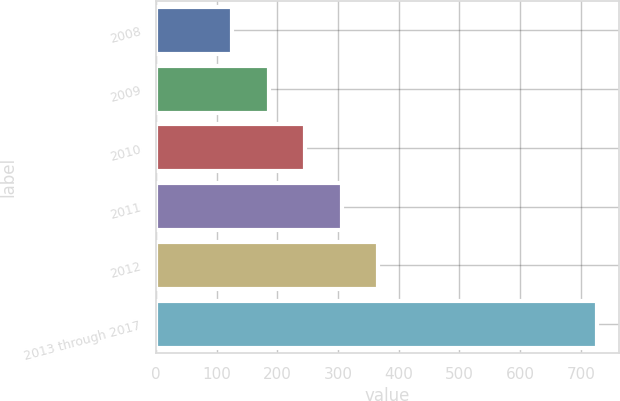<chart> <loc_0><loc_0><loc_500><loc_500><bar_chart><fcel>2008<fcel>2009<fcel>2010<fcel>2011<fcel>2012<fcel>2013 through 2017<nl><fcel>126<fcel>186<fcel>246<fcel>306<fcel>366<fcel>726<nl></chart> 